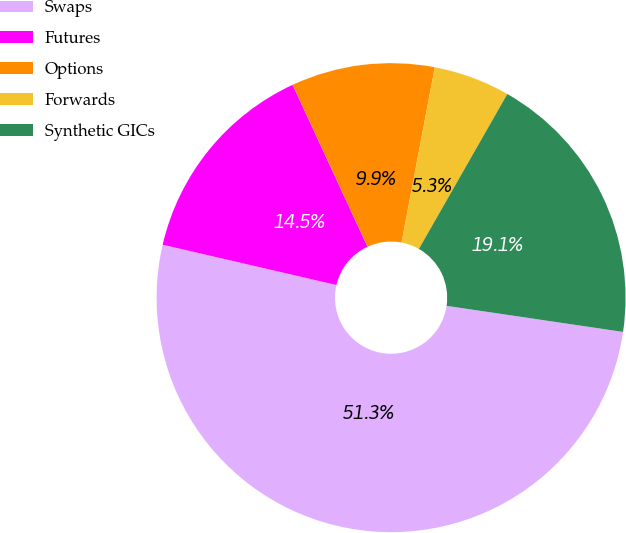<chart> <loc_0><loc_0><loc_500><loc_500><pie_chart><fcel>Swaps<fcel>Futures<fcel>Options<fcel>Forwards<fcel>Synthetic GICs<nl><fcel>51.29%<fcel>14.48%<fcel>9.88%<fcel>5.27%<fcel>19.08%<nl></chart> 